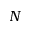Convert formula to latex. <formula><loc_0><loc_0><loc_500><loc_500>N</formula> 